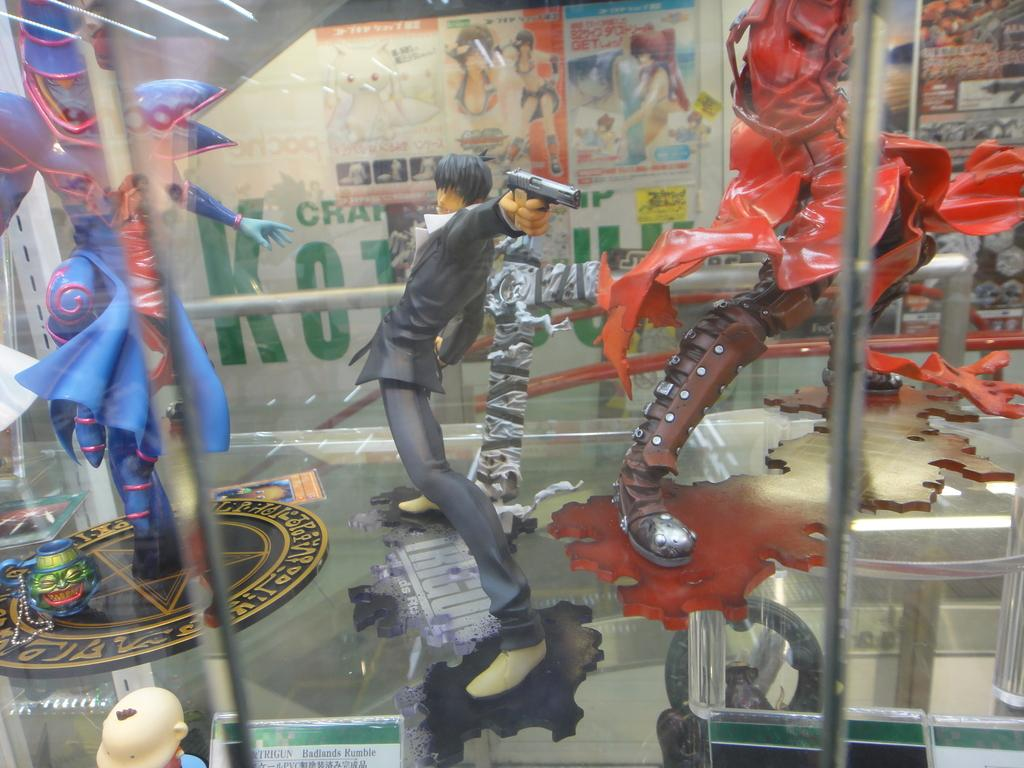What type of objects can be seen in the image? There are toys in the image. What can be seen in the background of the image? There are posters in the background of the image. What type of ice can be seen on the trousers in the image? There is no ice or trousers present in the image; it features toys and posters. 